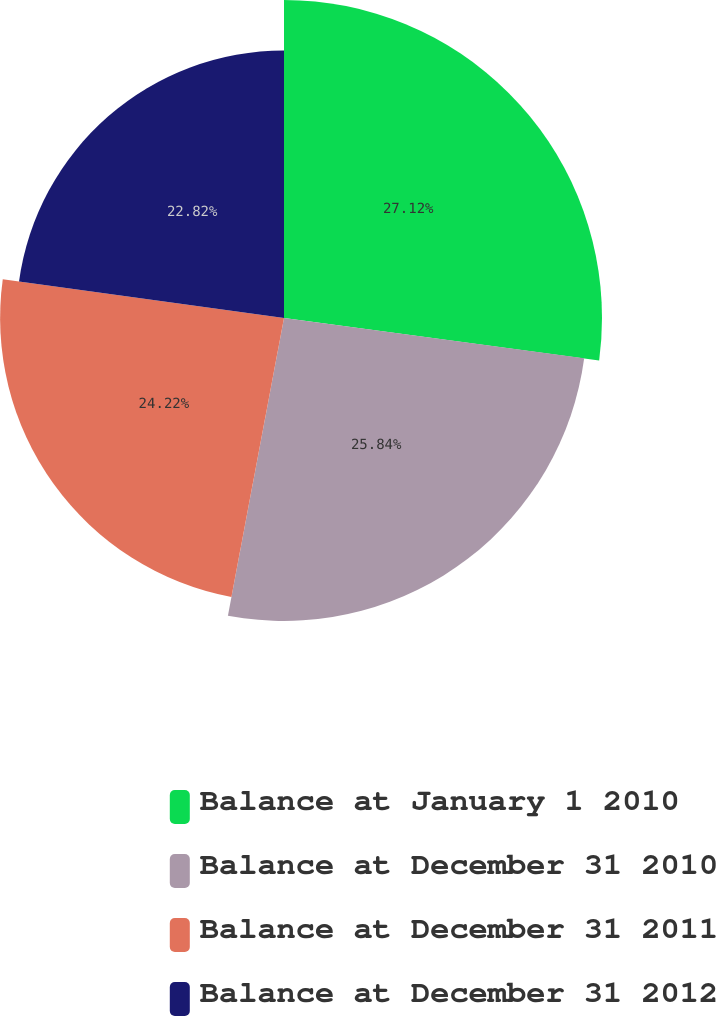Convert chart. <chart><loc_0><loc_0><loc_500><loc_500><pie_chart><fcel>Balance at January 1 2010<fcel>Balance at December 31 2010<fcel>Balance at December 31 2011<fcel>Balance at December 31 2012<nl><fcel>27.13%<fcel>25.84%<fcel>24.22%<fcel>22.82%<nl></chart> 